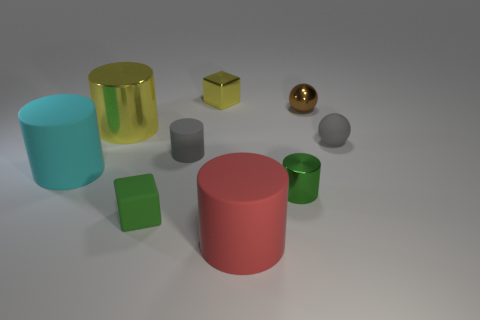Subtract all big yellow cylinders. How many cylinders are left? 4 Add 1 large brown cylinders. How many objects exist? 10 Subtract all balls. How many objects are left? 7 Subtract all gray cylinders. How many cylinders are left? 4 Subtract 1 cyan cylinders. How many objects are left? 8 Subtract 4 cylinders. How many cylinders are left? 1 Subtract all green cylinders. Subtract all green balls. How many cylinders are left? 4 Subtract all green cubes. How many gray spheres are left? 1 Subtract all metallic blocks. Subtract all green metal objects. How many objects are left? 7 Add 2 tiny matte things. How many tiny matte things are left? 5 